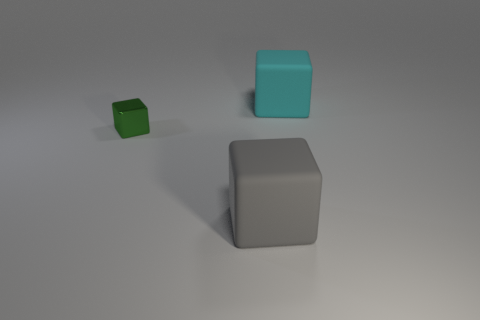Is there a gray metal object?
Your answer should be compact. No. Is the number of shiny blocks less than the number of big cubes?
Your answer should be compact. Yes. The green metallic object that is behind the block in front of the tiny shiny cube is what shape?
Provide a succinct answer. Cube. There is a cyan thing; are there any rubber blocks left of it?
Your response must be concise. Yes. The other matte thing that is the same size as the gray object is what color?
Ensure brevity in your answer.  Cyan. What number of large things have the same material as the small cube?
Keep it short and to the point. 0. What number of other objects are there of the same size as the cyan thing?
Keep it short and to the point. 1. Are there any metallic blocks of the same size as the gray object?
Your response must be concise. No. What number of things are big rubber things or tiny green blocks?
Make the answer very short. 3. Does the rubber object that is in front of the cyan matte cube have the same size as the tiny thing?
Keep it short and to the point. No. 